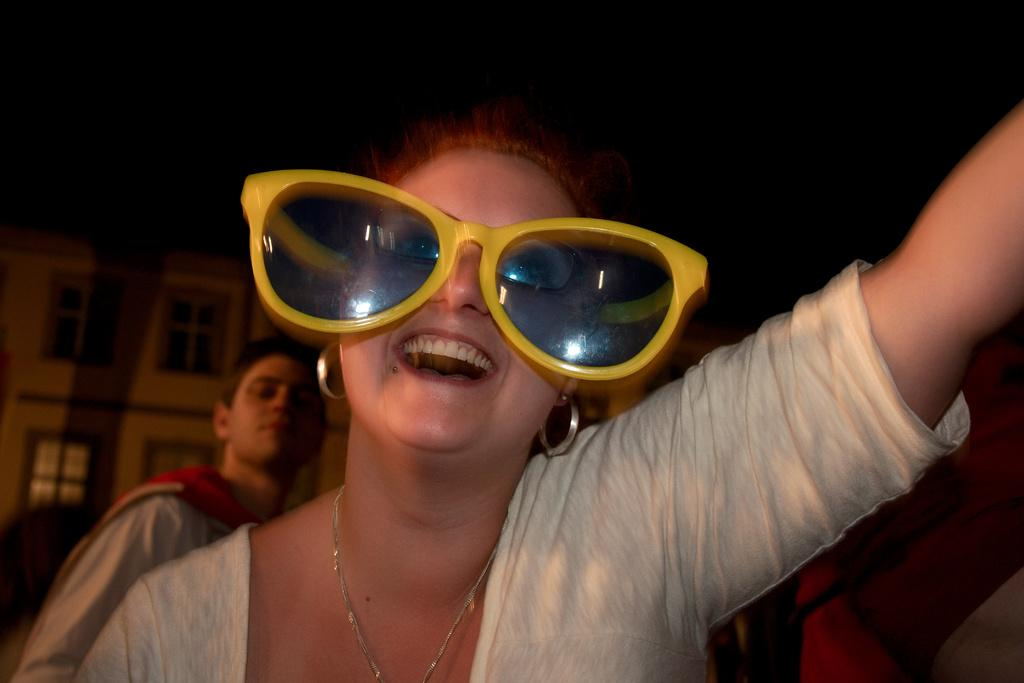What can be observed about the people in the image? There are people standing in the image. Can you describe the appearance of one of the individuals? A woman is wearing sunglasses. What might be visible in the distance behind the people? There might be a building in the background of the image. What type of whip is being used by the woman in the image? There is no whip present in the image. How many carts are visible in the image? There are no carts visible in the image. 